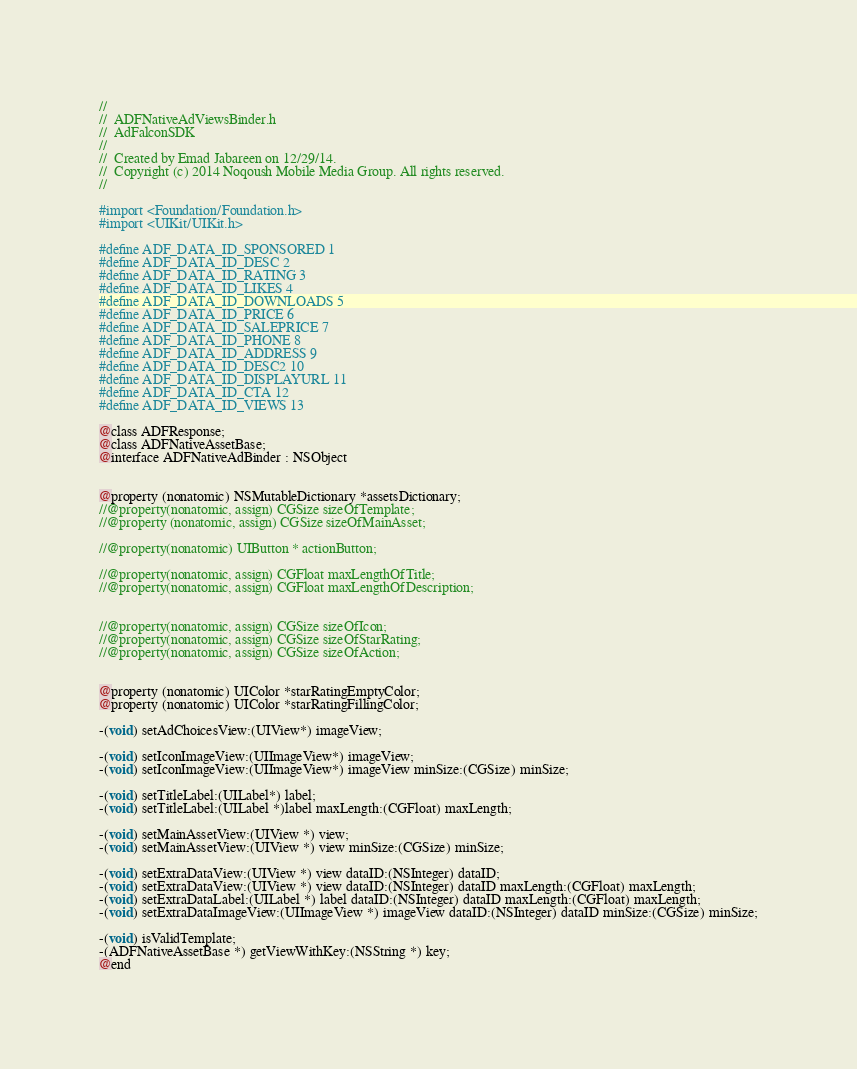<code> <loc_0><loc_0><loc_500><loc_500><_C_>//
//  ADFNativeAdViewsBinder.h
//  AdFalconSDK
//
//  Created by Emad Jabareen on 12/29/14.
//  Copyright (c) 2014 Noqoush Mobile Media Group. All rights reserved.
//

#import <Foundation/Foundation.h>
#import <UIKit/UIKit.h>

#define ADF_DATA_ID_SPONSORED 1
#define ADF_DATA_ID_DESC 2
#define ADF_DATA_ID_RATING 3
#define ADF_DATA_ID_LIKES 4
#define ADF_DATA_ID_DOWNLOADS 5
#define ADF_DATA_ID_PRICE 6
#define ADF_DATA_ID_SALEPRICE 7
#define ADF_DATA_ID_PHONE 8
#define ADF_DATA_ID_ADDRESS 9
#define ADF_DATA_ID_DESC2 10
#define ADF_DATA_ID_DISPLAYURL 11
#define ADF_DATA_ID_CTA 12
#define ADF_DATA_ID_VIEWS 13

@class ADFResponse;
@class ADFNativeAssetBase;
@interface ADFNativeAdBinder : NSObject


@property (nonatomic) NSMutableDictionary *assetsDictionary;
//@property(nonatomic, assign) CGSize sizeOfTemplate;
//@property (nonatomic, assign) CGSize sizeOfMainAsset;

//@property(nonatomic) UIButton * actionButton;

//@property(nonatomic, assign) CGFloat maxLengthOfTitle;
//@property(nonatomic, assign) CGFloat maxLengthOfDescription;


//@property(nonatomic, assign) CGSize sizeOfIcon;
//@property(nonatomic, assign) CGSize sizeOfStarRating;
//@property(nonatomic, assign) CGSize sizeOfAction;


@property (nonatomic) UIColor *starRatingEmptyColor;
@property (nonatomic) UIColor *starRatingFillingColor;

-(void) setAdChoicesView:(UIView*) imageView;

-(void) setIconImageView:(UIImageView*) imageView;
-(void) setIconImageView:(UIImageView*) imageView minSize:(CGSize) minSize;

-(void) setTitleLabel:(UILabel*) label;
-(void) setTitleLabel:(UILabel *)label maxLength:(CGFloat) maxLength;

-(void) setMainAssetView:(UIView *) view;
-(void) setMainAssetView:(UIView *) view minSize:(CGSize) minSize;

-(void) setExtraDataView:(UIView *) view dataID:(NSInteger) dataID;
-(void) setExtraDataView:(UIView *) view dataID:(NSInteger) dataID maxLength:(CGFloat) maxLength;
-(void) setExtraDataLabel:(UILabel *) label dataID:(NSInteger) dataID maxLength:(CGFloat) maxLength;
-(void) setExtraDataImageView:(UIImageView *) imageView dataID:(NSInteger) dataID minSize:(CGSize) minSize;

-(void) isValidTemplate;
-(ADFNativeAssetBase *) getViewWithKey:(NSString *) key;
@end
</code> 